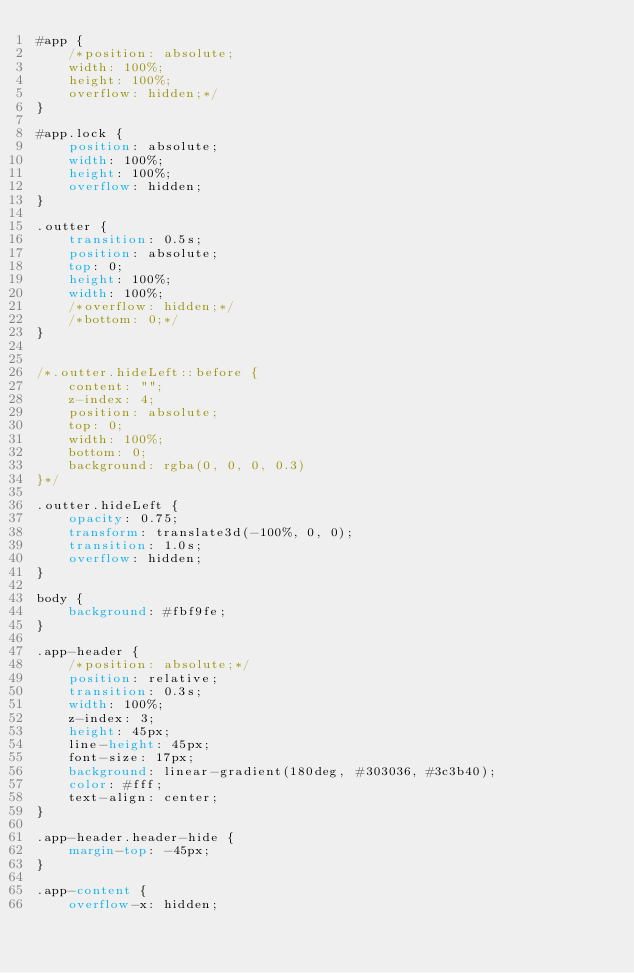<code> <loc_0><loc_0><loc_500><loc_500><_CSS_>#app {
    /*position: absolute;
    width: 100%;
    height: 100%;
    overflow: hidden;*/
}

#app.lock {
    position: absolute;
    width: 100%;
    height: 100%;
    overflow: hidden;
}

.outter {
    transition: 0.5s;
    position: absolute;
    top: 0;
    height: 100%;
    width: 100%;
    /*overflow: hidden;*/
    /*bottom: 0;*/
}


/*.outter.hideLeft::before {
    content: "";
    z-index: 4;
    position: absolute;
    top: 0;
    width: 100%;
    bottom: 0;
    background: rgba(0, 0, 0, 0.3)
}*/

.outter.hideLeft {
    opacity: 0.75;
    transform: translate3d(-100%, 0, 0);
    transition: 1.0s;
    overflow: hidden;
}

body {
    background: #fbf9fe;
}

.app-header {
    /*position: absolute;*/
    position: relative;
    transition: 0.3s;
    width: 100%;
    z-index: 3;
    height: 45px;
    line-height: 45px;
    font-size: 17px;
    background: linear-gradient(180deg, #303036, #3c3b40);
    color: #fff;
    text-align: center;
}

.app-header.header-hide {
    margin-top: -45px;
}

.app-content {
    overflow-x: hidden;</code> 